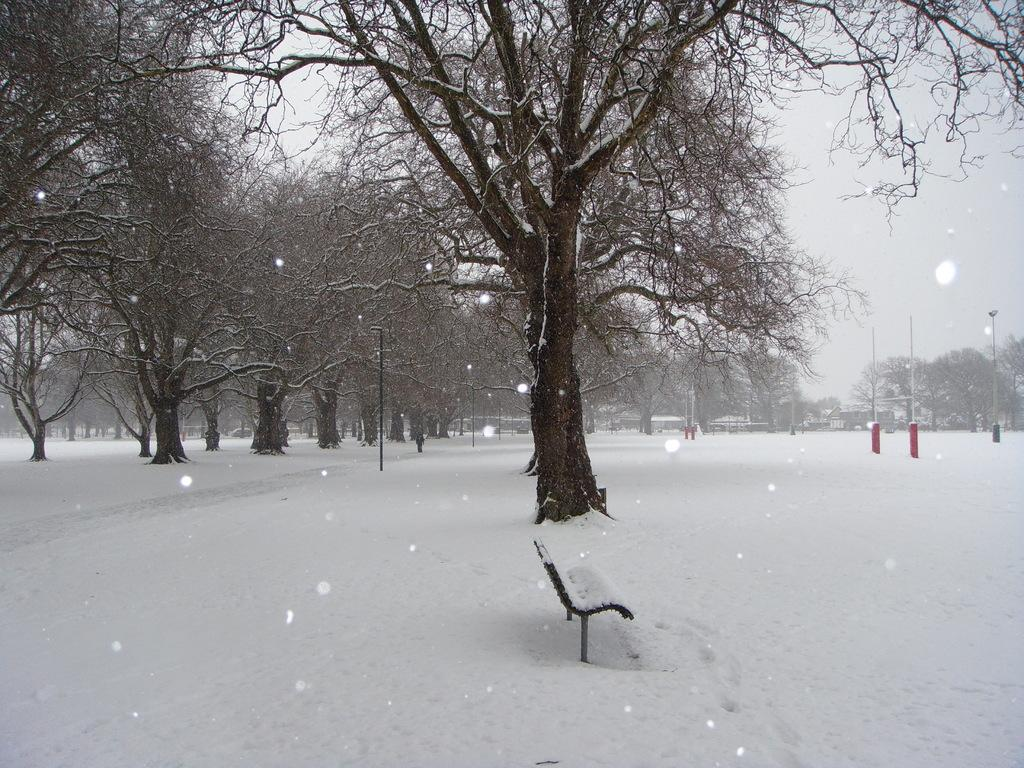What type of surface is visible in the image? There is a snow surface in the image. What is located on the snow surface? There is a bench on the snow surface. What can be seen beside the bench? There is a row of trees beside the bench. What is visible in the background of the image? There are many trees and the sky visible in the background of the image. Can you see a wristwatch on any of the trees in the image? There is no wristwatch present on any of the trees in the image. Are there any cows visible in the image? There are no cows present in the image. 